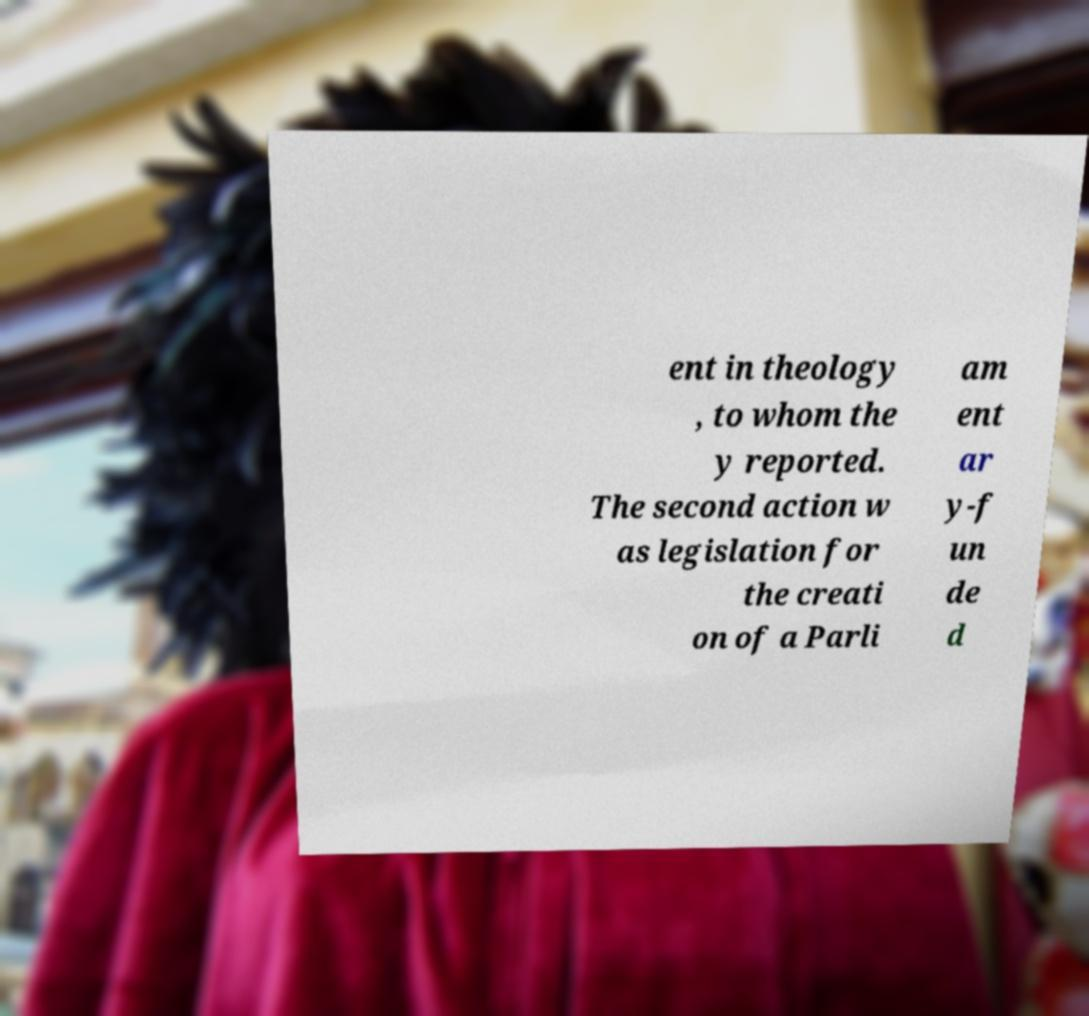Could you extract and type out the text from this image? ent in theology , to whom the y reported. The second action w as legislation for the creati on of a Parli am ent ar y-f un de d 